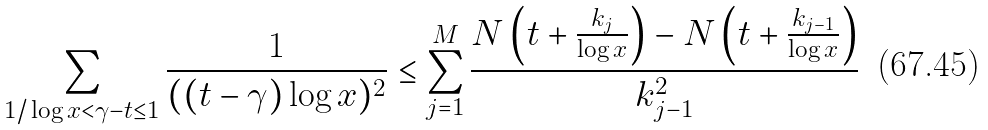<formula> <loc_0><loc_0><loc_500><loc_500>\sum _ { 1 / \log x < \gamma - t \leq 1 } \frac { 1 } { ( ( t - \gamma ) \log x ) ^ { 2 } } \leq \sum _ { j = 1 } ^ { M } \frac { N \left ( t + \frac { k _ { j } } { \log x } \right ) - N \left ( t + \frac { k _ { j - 1 } } { \log x } \right ) } { k _ { j - 1 } ^ { 2 } }</formula> 